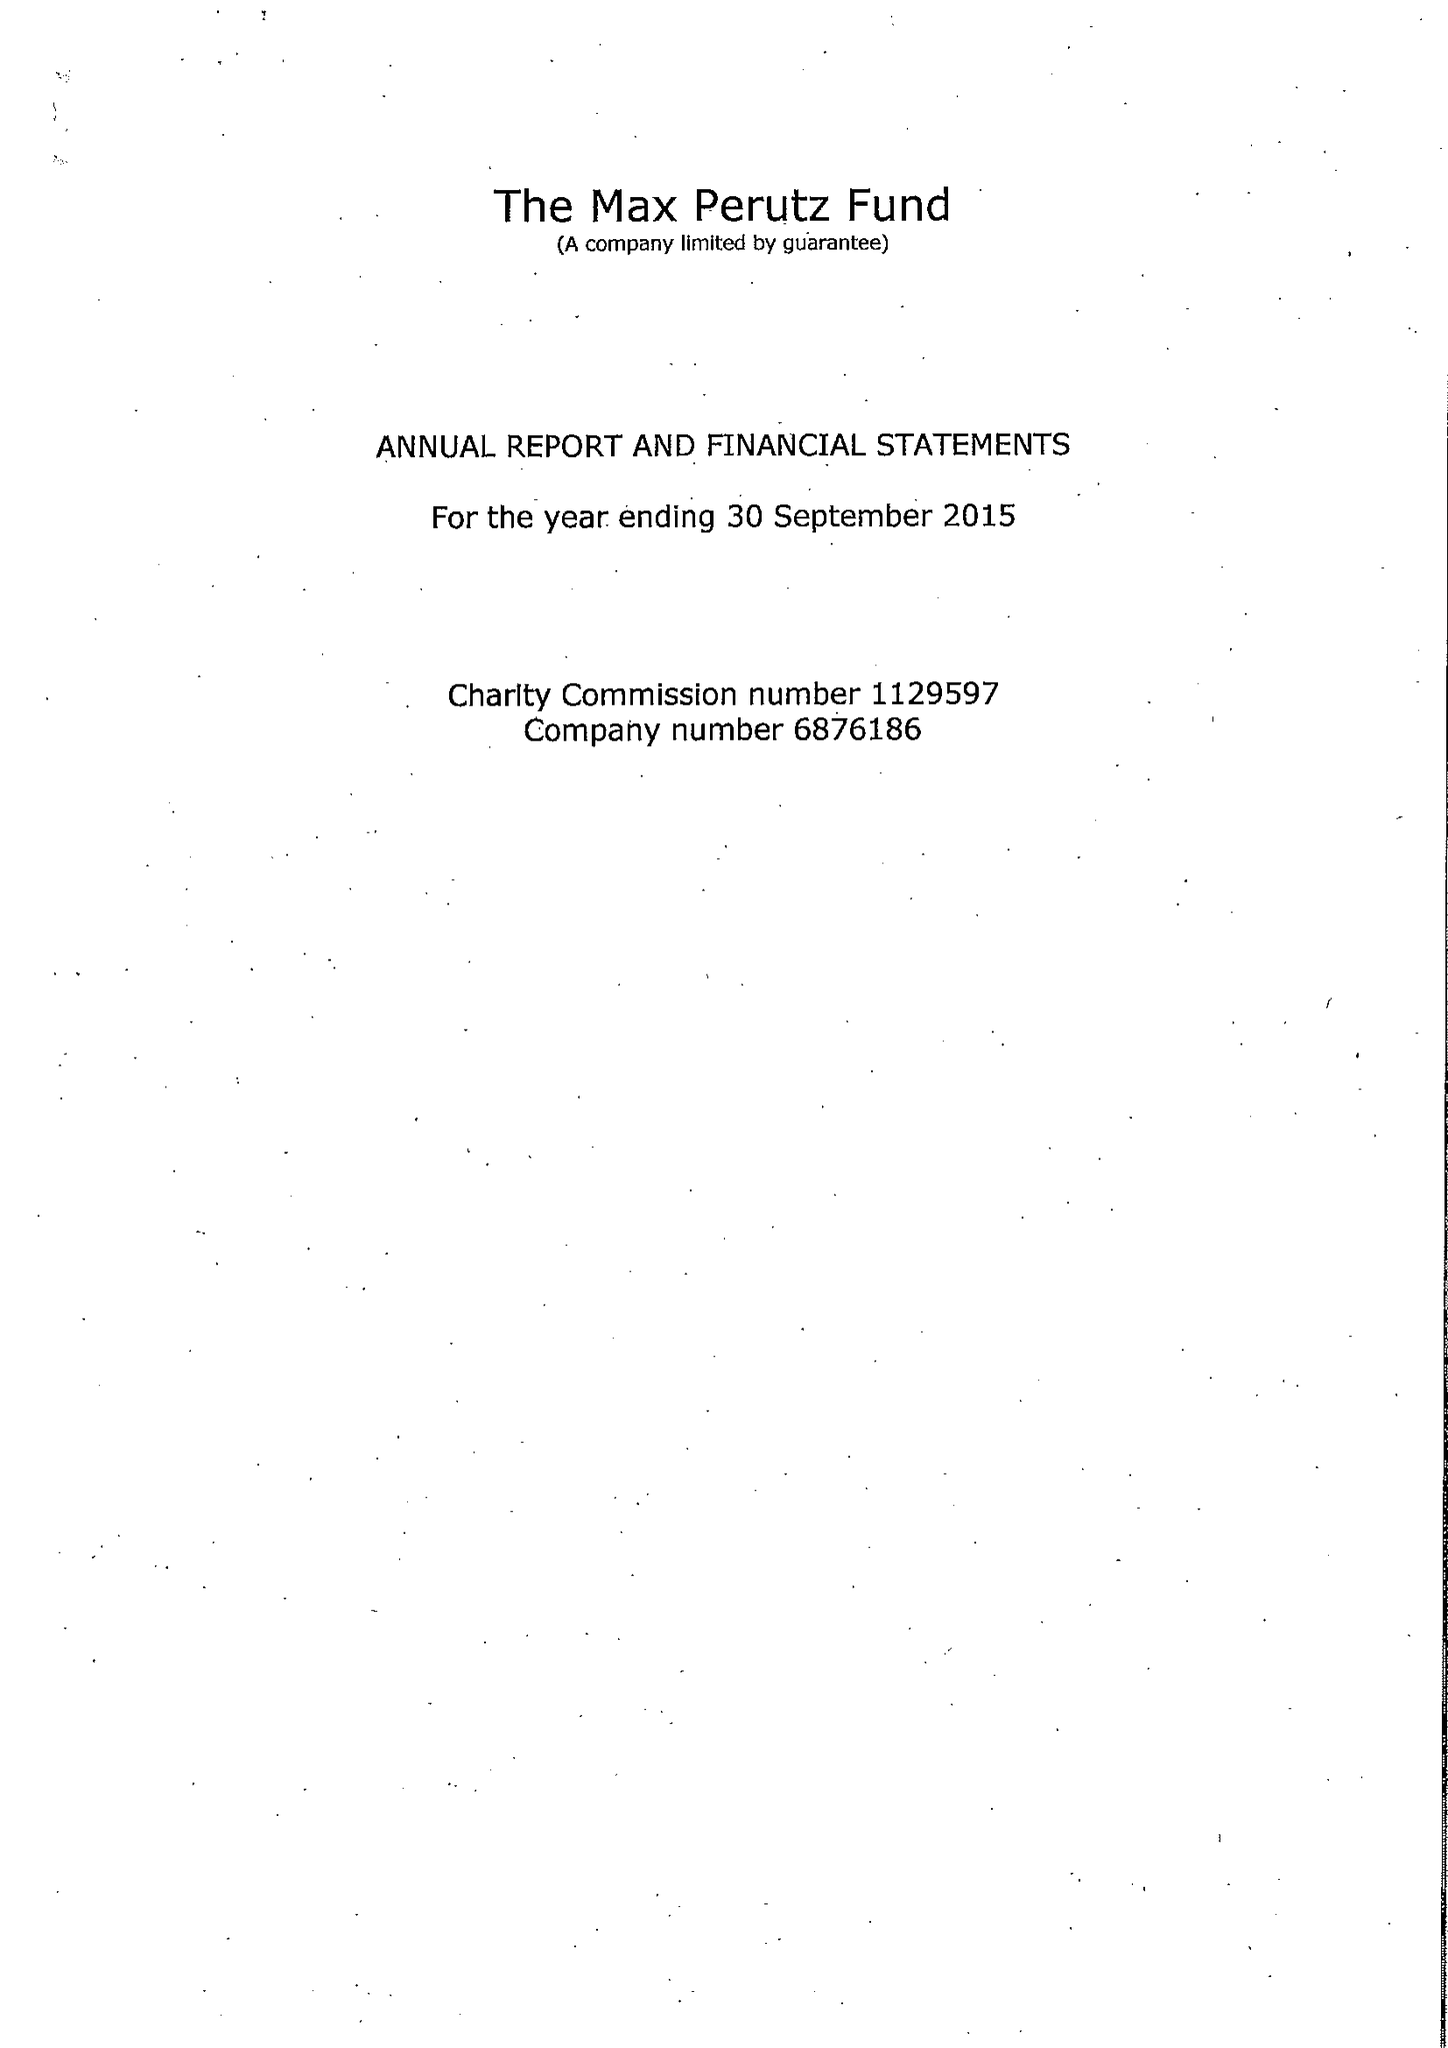What is the value for the spending_annually_in_british_pounds?
Answer the question using a single word or phrase. 217495.00 